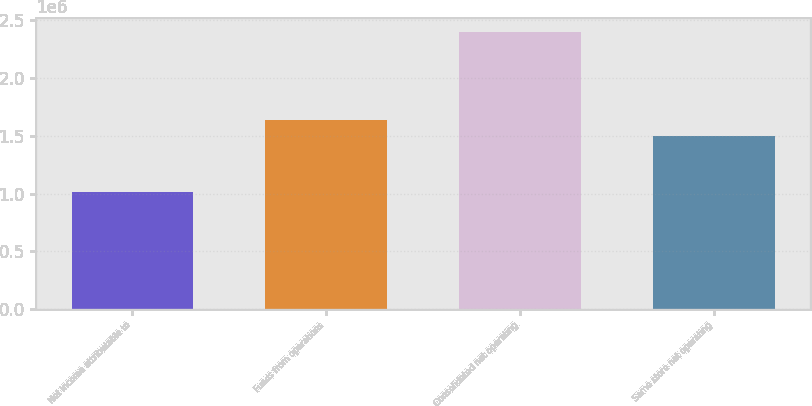Convert chart to OTSL. <chart><loc_0><loc_0><loc_500><loc_500><bar_chart><fcel>Net income attributable to<fcel>Funds from operations<fcel>Consolidated net operating<fcel>Same store net operating<nl><fcel>1.0124e+06<fcel>1.63869e+06<fcel>2.40418e+06<fcel>1.49951e+06<nl></chart> 